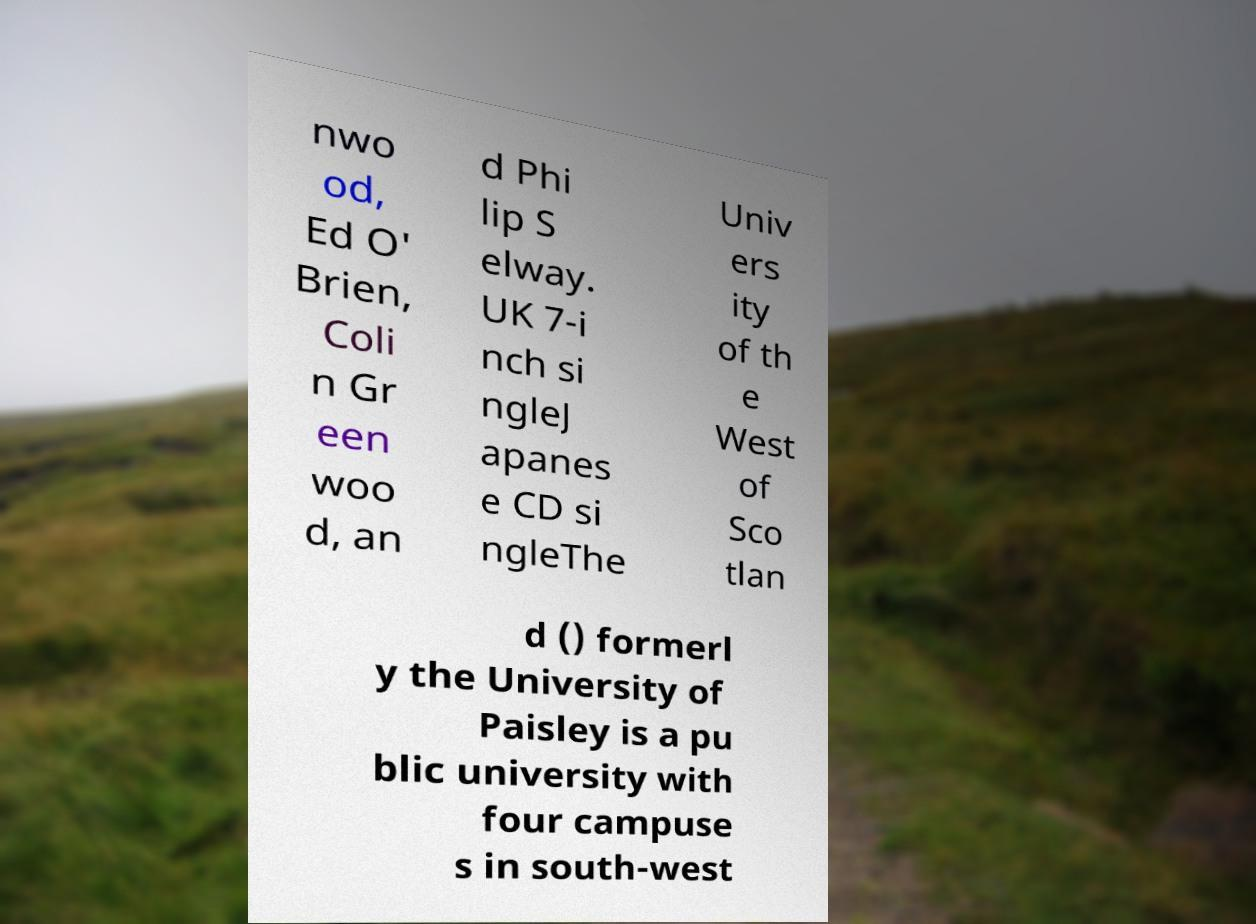Please read and relay the text visible in this image. What does it say? nwo od, Ed O' Brien, Coli n Gr een woo d, an d Phi lip S elway. UK 7-i nch si ngleJ apanes e CD si ngleThe Univ ers ity of th e West of Sco tlan d () formerl y the University of Paisley is a pu blic university with four campuse s in south-west 